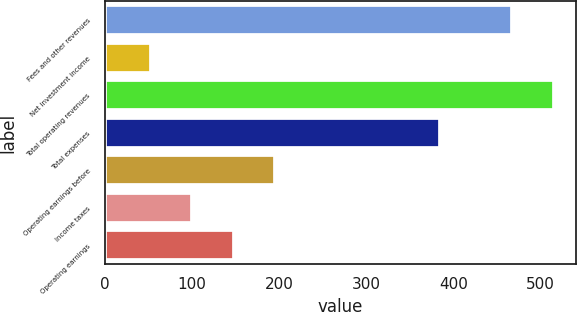Convert chart. <chart><loc_0><loc_0><loc_500><loc_500><bar_chart><fcel>Fees and other revenues<fcel>Net investment income<fcel>Total operating revenues<fcel>Total expenses<fcel>Operating earnings before<fcel>Income taxes<fcel>Operating earnings<nl><fcel>467.2<fcel>52.64<fcel>514.84<fcel>384.2<fcel>195.56<fcel>100.28<fcel>147.92<nl></chart> 